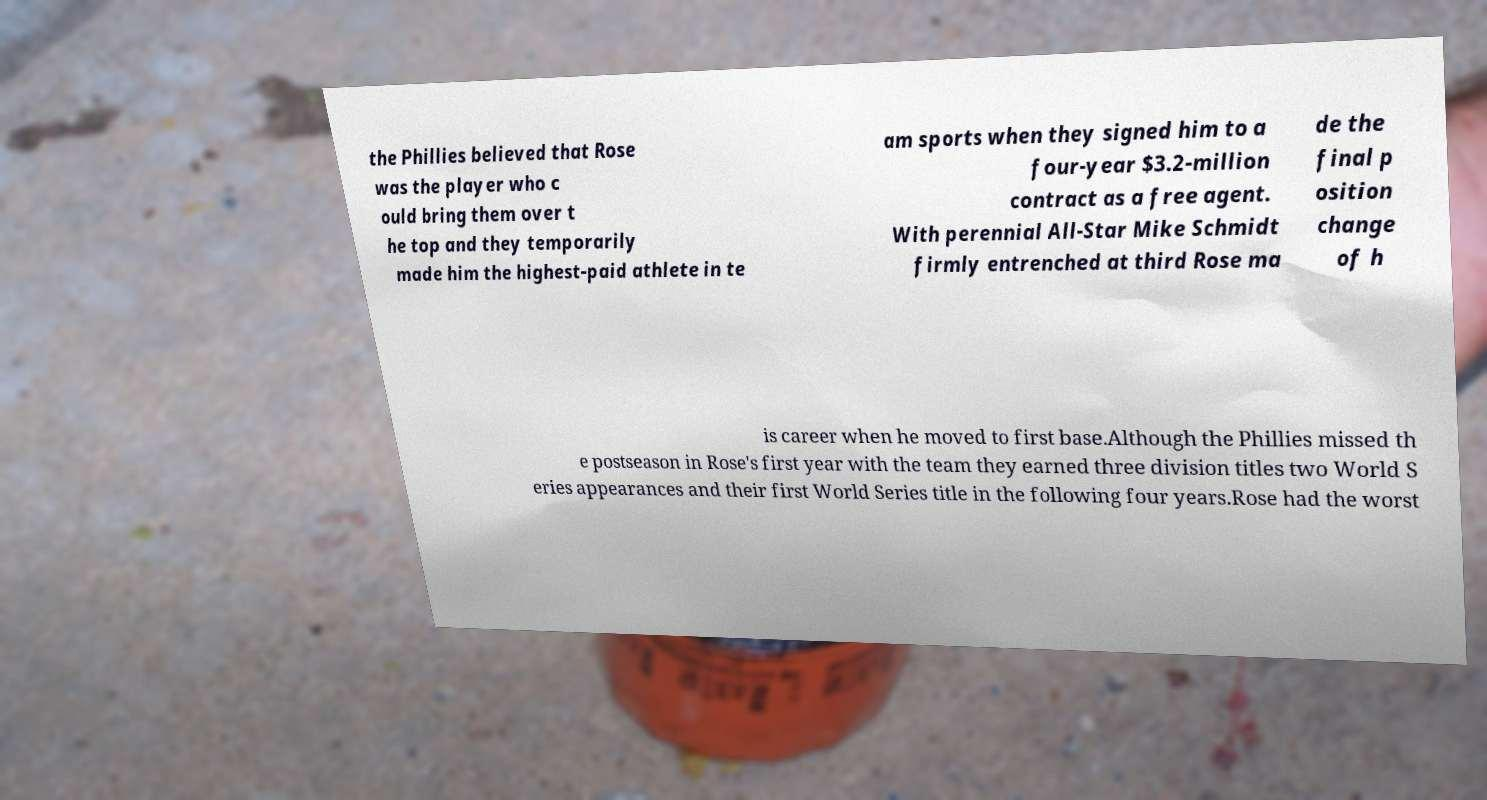Could you extract and type out the text from this image? the Phillies believed that Rose was the player who c ould bring them over t he top and they temporarily made him the highest-paid athlete in te am sports when they signed him to a four-year $3.2-million contract as a free agent. With perennial All-Star Mike Schmidt firmly entrenched at third Rose ma de the final p osition change of h is career when he moved to first base.Although the Phillies missed th e postseason in Rose's first year with the team they earned three division titles two World S eries appearances and their first World Series title in the following four years.Rose had the worst 